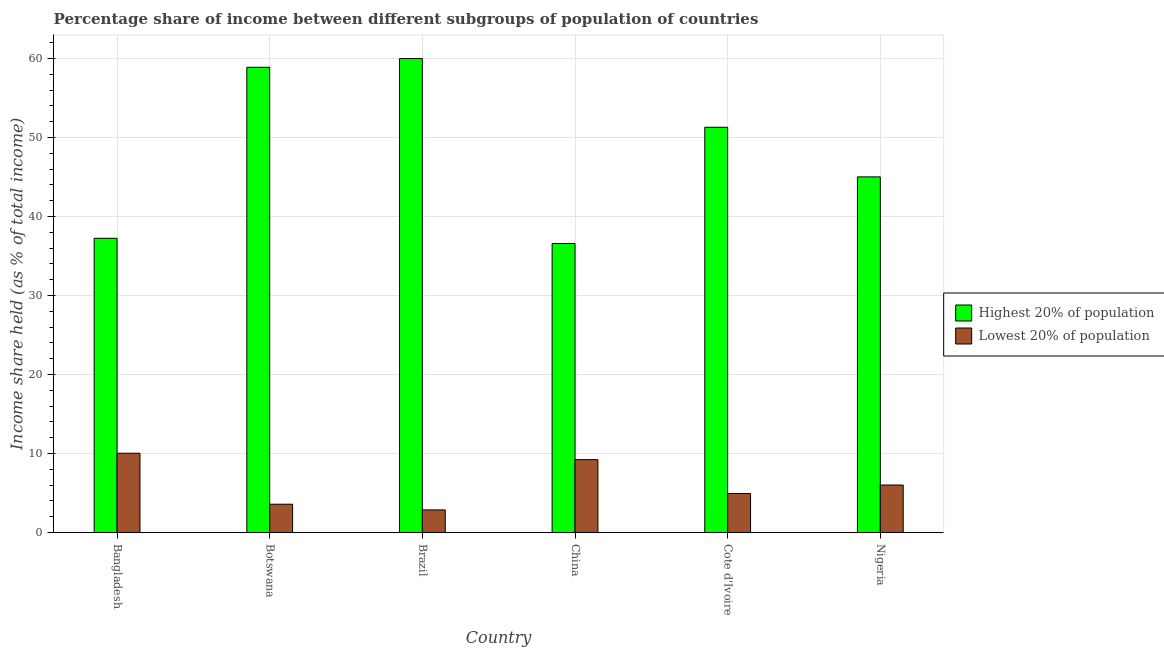How many different coloured bars are there?
Offer a terse response. 2. How many groups of bars are there?
Provide a succinct answer. 6. Are the number of bars per tick equal to the number of legend labels?
Your answer should be compact. Yes. Are the number of bars on each tick of the X-axis equal?
Your answer should be very brief. Yes. How many bars are there on the 5th tick from the left?
Make the answer very short. 2. In how many cases, is the number of bars for a given country not equal to the number of legend labels?
Give a very brief answer. 0. What is the income share held by highest 20% of the population in Nigeria?
Offer a terse response. 45.01. Across all countries, what is the maximum income share held by lowest 20% of the population?
Keep it short and to the point. 10.04. Across all countries, what is the minimum income share held by highest 20% of the population?
Offer a very short reply. 36.58. In which country was the income share held by lowest 20% of the population minimum?
Keep it short and to the point. Brazil. What is the total income share held by lowest 20% of the population in the graph?
Give a very brief answer. 36.7. What is the difference between the income share held by lowest 20% of the population in China and that in Cote d'Ivoire?
Keep it short and to the point. 4.28. What is the difference between the income share held by highest 20% of the population in Botswana and the income share held by lowest 20% of the population in Nigeria?
Ensure brevity in your answer.  52.86. What is the average income share held by lowest 20% of the population per country?
Offer a terse response. 6.12. What is the difference between the income share held by highest 20% of the population and income share held by lowest 20% of the population in Cote d'Ivoire?
Ensure brevity in your answer.  46.34. In how many countries, is the income share held by highest 20% of the population greater than 26 %?
Make the answer very short. 6. What is the ratio of the income share held by lowest 20% of the population in Botswana to that in China?
Provide a short and direct response. 0.39. Is the difference between the income share held by lowest 20% of the population in Bangladesh and Brazil greater than the difference between the income share held by highest 20% of the population in Bangladesh and Brazil?
Provide a succinct answer. Yes. What is the difference between the highest and the second highest income share held by lowest 20% of the population?
Give a very brief answer. 0.81. What is the difference between the highest and the lowest income share held by lowest 20% of the population?
Ensure brevity in your answer.  7.17. In how many countries, is the income share held by highest 20% of the population greater than the average income share held by highest 20% of the population taken over all countries?
Offer a very short reply. 3. Is the sum of the income share held by highest 20% of the population in Bangladesh and Botswana greater than the maximum income share held by lowest 20% of the population across all countries?
Your answer should be very brief. Yes. What does the 1st bar from the left in Nigeria represents?
Ensure brevity in your answer.  Highest 20% of population. What does the 2nd bar from the right in Botswana represents?
Provide a short and direct response. Highest 20% of population. How many countries are there in the graph?
Provide a short and direct response. 6. Are the values on the major ticks of Y-axis written in scientific E-notation?
Offer a terse response. No. Does the graph contain any zero values?
Keep it short and to the point. No. Does the graph contain grids?
Give a very brief answer. Yes. How many legend labels are there?
Your answer should be compact. 2. How are the legend labels stacked?
Provide a short and direct response. Vertical. What is the title of the graph?
Make the answer very short. Percentage share of income between different subgroups of population of countries. Does "Pregnant women" appear as one of the legend labels in the graph?
Give a very brief answer. No. What is the label or title of the X-axis?
Ensure brevity in your answer.  Country. What is the label or title of the Y-axis?
Ensure brevity in your answer.  Income share held (as % of total income). What is the Income share held (as % of total income) in Highest 20% of population in Bangladesh?
Make the answer very short. 37.24. What is the Income share held (as % of total income) in Lowest 20% of population in Bangladesh?
Offer a terse response. 10.04. What is the Income share held (as % of total income) in Highest 20% of population in Botswana?
Your response must be concise. 58.88. What is the Income share held (as % of total income) of Lowest 20% of population in Botswana?
Keep it short and to the point. 3.59. What is the Income share held (as % of total income) in Highest 20% of population in Brazil?
Your answer should be very brief. 59.98. What is the Income share held (as % of total income) of Lowest 20% of population in Brazil?
Provide a short and direct response. 2.87. What is the Income share held (as % of total income) in Highest 20% of population in China?
Offer a very short reply. 36.58. What is the Income share held (as % of total income) of Lowest 20% of population in China?
Give a very brief answer. 9.23. What is the Income share held (as % of total income) of Highest 20% of population in Cote d'Ivoire?
Make the answer very short. 51.29. What is the Income share held (as % of total income) of Lowest 20% of population in Cote d'Ivoire?
Make the answer very short. 4.95. What is the Income share held (as % of total income) in Highest 20% of population in Nigeria?
Make the answer very short. 45.01. What is the Income share held (as % of total income) of Lowest 20% of population in Nigeria?
Ensure brevity in your answer.  6.02. Across all countries, what is the maximum Income share held (as % of total income) in Highest 20% of population?
Ensure brevity in your answer.  59.98. Across all countries, what is the maximum Income share held (as % of total income) in Lowest 20% of population?
Your answer should be compact. 10.04. Across all countries, what is the minimum Income share held (as % of total income) of Highest 20% of population?
Provide a succinct answer. 36.58. Across all countries, what is the minimum Income share held (as % of total income) in Lowest 20% of population?
Provide a succinct answer. 2.87. What is the total Income share held (as % of total income) of Highest 20% of population in the graph?
Your answer should be very brief. 288.98. What is the total Income share held (as % of total income) of Lowest 20% of population in the graph?
Give a very brief answer. 36.7. What is the difference between the Income share held (as % of total income) of Highest 20% of population in Bangladesh and that in Botswana?
Your response must be concise. -21.64. What is the difference between the Income share held (as % of total income) in Lowest 20% of population in Bangladesh and that in Botswana?
Keep it short and to the point. 6.45. What is the difference between the Income share held (as % of total income) of Highest 20% of population in Bangladesh and that in Brazil?
Ensure brevity in your answer.  -22.74. What is the difference between the Income share held (as % of total income) of Lowest 20% of population in Bangladesh and that in Brazil?
Keep it short and to the point. 7.17. What is the difference between the Income share held (as % of total income) in Highest 20% of population in Bangladesh and that in China?
Give a very brief answer. 0.66. What is the difference between the Income share held (as % of total income) in Lowest 20% of population in Bangladesh and that in China?
Ensure brevity in your answer.  0.81. What is the difference between the Income share held (as % of total income) of Highest 20% of population in Bangladesh and that in Cote d'Ivoire?
Ensure brevity in your answer.  -14.05. What is the difference between the Income share held (as % of total income) of Lowest 20% of population in Bangladesh and that in Cote d'Ivoire?
Provide a succinct answer. 5.09. What is the difference between the Income share held (as % of total income) of Highest 20% of population in Bangladesh and that in Nigeria?
Your response must be concise. -7.77. What is the difference between the Income share held (as % of total income) of Lowest 20% of population in Bangladesh and that in Nigeria?
Give a very brief answer. 4.02. What is the difference between the Income share held (as % of total income) of Highest 20% of population in Botswana and that in Brazil?
Your answer should be very brief. -1.1. What is the difference between the Income share held (as % of total income) in Lowest 20% of population in Botswana and that in Brazil?
Provide a succinct answer. 0.72. What is the difference between the Income share held (as % of total income) in Highest 20% of population in Botswana and that in China?
Keep it short and to the point. 22.3. What is the difference between the Income share held (as % of total income) of Lowest 20% of population in Botswana and that in China?
Your answer should be very brief. -5.64. What is the difference between the Income share held (as % of total income) in Highest 20% of population in Botswana and that in Cote d'Ivoire?
Give a very brief answer. 7.59. What is the difference between the Income share held (as % of total income) in Lowest 20% of population in Botswana and that in Cote d'Ivoire?
Give a very brief answer. -1.36. What is the difference between the Income share held (as % of total income) in Highest 20% of population in Botswana and that in Nigeria?
Give a very brief answer. 13.87. What is the difference between the Income share held (as % of total income) of Lowest 20% of population in Botswana and that in Nigeria?
Your response must be concise. -2.43. What is the difference between the Income share held (as % of total income) of Highest 20% of population in Brazil and that in China?
Provide a short and direct response. 23.4. What is the difference between the Income share held (as % of total income) of Lowest 20% of population in Brazil and that in China?
Offer a very short reply. -6.36. What is the difference between the Income share held (as % of total income) of Highest 20% of population in Brazil and that in Cote d'Ivoire?
Ensure brevity in your answer.  8.69. What is the difference between the Income share held (as % of total income) of Lowest 20% of population in Brazil and that in Cote d'Ivoire?
Offer a terse response. -2.08. What is the difference between the Income share held (as % of total income) in Highest 20% of population in Brazil and that in Nigeria?
Keep it short and to the point. 14.97. What is the difference between the Income share held (as % of total income) of Lowest 20% of population in Brazil and that in Nigeria?
Keep it short and to the point. -3.15. What is the difference between the Income share held (as % of total income) in Highest 20% of population in China and that in Cote d'Ivoire?
Ensure brevity in your answer.  -14.71. What is the difference between the Income share held (as % of total income) of Lowest 20% of population in China and that in Cote d'Ivoire?
Provide a succinct answer. 4.28. What is the difference between the Income share held (as % of total income) in Highest 20% of population in China and that in Nigeria?
Your answer should be compact. -8.43. What is the difference between the Income share held (as % of total income) of Lowest 20% of population in China and that in Nigeria?
Keep it short and to the point. 3.21. What is the difference between the Income share held (as % of total income) of Highest 20% of population in Cote d'Ivoire and that in Nigeria?
Your answer should be compact. 6.28. What is the difference between the Income share held (as % of total income) of Lowest 20% of population in Cote d'Ivoire and that in Nigeria?
Give a very brief answer. -1.07. What is the difference between the Income share held (as % of total income) of Highest 20% of population in Bangladesh and the Income share held (as % of total income) of Lowest 20% of population in Botswana?
Ensure brevity in your answer.  33.65. What is the difference between the Income share held (as % of total income) in Highest 20% of population in Bangladesh and the Income share held (as % of total income) in Lowest 20% of population in Brazil?
Provide a succinct answer. 34.37. What is the difference between the Income share held (as % of total income) of Highest 20% of population in Bangladesh and the Income share held (as % of total income) of Lowest 20% of population in China?
Offer a terse response. 28.01. What is the difference between the Income share held (as % of total income) in Highest 20% of population in Bangladesh and the Income share held (as % of total income) in Lowest 20% of population in Cote d'Ivoire?
Offer a very short reply. 32.29. What is the difference between the Income share held (as % of total income) of Highest 20% of population in Bangladesh and the Income share held (as % of total income) of Lowest 20% of population in Nigeria?
Keep it short and to the point. 31.22. What is the difference between the Income share held (as % of total income) in Highest 20% of population in Botswana and the Income share held (as % of total income) in Lowest 20% of population in Brazil?
Make the answer very short. 56.01. What is the difference between the Income share held (as % of total income) of Highest 20% of population in Botswana and the Income share held (as % of total income) of Lowest 20% of population in China?
Provide a short and direct response. 49.65. What is the difference between the Income share held (as % of total income) of Highest 20% of population in Botswana and the Income share held (as % of total income) of Lowest 20% of population in Cote d'Ivoire?
Keep it short and to the point. 53.93. What is the difference between the Income share held (as % of total income) of Highest 20% of population in Botswana and the Income share held (as % of total income) of Lowest 20% of population in Nigeria?
Provide a succinct answer. 52.86. What is the difference between the Income share held (as % of total income) of Highest 20% of population in Brazil and the Income share held (as % of total income) of Lowest 20% of population in China?
Your answer should be very brief. 50.75. What is the difference between the Income share held (as % of total income) of Highest 20% of population in Brazil and the Income share held (as % of total income) of Lowest 20% of population in Cote d'Ivoire?
Offer a very short reply. 55.03. What is the difference between the Income share held (as % of total income) in Highest 20% of population in Brazil and the Income share held (as % of total income) in Lowest 20% of population in Nigeria?
Give a very brief answer. 53.96. What is the difference between the Income share held (as % of total income) of Highest 20% of population in China and the Income share held (as % of total income) of Lowest 20% of population in Cote d'Ivoire?
Provide a succinct answer. 31.63. What is the difference between the Income share held (as % of total income) of Highest 20% of population in China and the Income share held (as % of total income) of Lowest 20% of population in Nigeria?
Make the answer very short. 30.56. What is the difference between the Income share held (as % of total income) in Highest 20% of population in Cote d'Ivoire and the Income share held (as % of total income) in Lowest 20% of population in Nigeria?
Your response must be concise. 45.27. What is the average Income share held (as % of total income) in Highest 20% of population per country?
Make the answer very short. 48.16. What is the average Income share held (as % of total income) in Lowest 20% of population per country?
Keep it short and to the point. 6.12. What is the difference between the Income share held (as % of total income) of Highest 20% of population and Income share held (as % of total income) of Lowest 20% of population in Bangladesh?
Make the answer very short. 27.2. What is the difference between the Income share held (as % of total income) of Highest 20% of population and Income share held (as % of total income) of Lowest 20% of population in Botswana?
Your answer should be very brief. 55.29. What is the difference between the Income share held (as % of total income) of Highest 20% of population and Income share held (as % of total income) of Lowest 20% of population in Brazil?
Provide a short and direct response. 57.11. What is the difference between the Income share held (as % of total income) of Highest 20% of population and Income share held (as % of total income) of Lowest 20% of population in China?
Provide a short and direct response. 27.35. What is the difference between the Income share held (as % of total income) of Highest 20% of population and Income share held (as % of total income) of Lowest 20% of population in Cote d'Ivoire?
Your answer should be compact. 46.34. What is the difference between the Income share held (as % of total income) in Highest 20% of population and Income share held (as % of total income) in Lowest 20% of population in Nigeria?
Give a very brief answer. 38.99. What is the ratio of the Income share held (as % of total income) of Highest 20% of population in Bangladesh to that in Botswana?
Your response must be concise. 0.63. What is the ratio of the Income share held (as % of total income) of Lowest 20% of population in Bangladesh to that in Botswana?
Ensure brevity in your answer.  2.8. What is the ratio of the Income share held (as % of total income) in Highest 20% of population in Bangladesh to that in Brazil?
Ensure brevity in your answer.  0.62. What is the ratio of the Income share held (as % of total income) in Lowest 20% of population in Bangladesh to that in Brazil?
Give a very brief answer. 3.5. What is the ratio of the Income share held (as % of total income) in Highest 20% of population in Bangladesh to that in China?
Keep it short and to the point. 1.02. What is the ratio of the Income share held (as % of total income) in Lowest 20% of population in Bangladesh to that in China?
Ensure brevity in your answer.  1.09. What is the ratio of the Income share held (as % of total income) of Highest 20% of population in Bangladesh to that in Cote d'Ivoire?
Provide a short and direct response. 0.73. What is the ratio of the Income share held (as % of total income) in Lowest 20% of population in Bangladesh to that in Cote d'Ivoire?
Make the answer very short. 2.03. What is the ratio of the Income share held (as % of total income) of Highest 20% of population in Bangladesh to that in Nigeria?
Ensure brevity in your answer.  0.83. What is the ratio of the Income share held (as % of total income) in Lowest 20% of population in Bangladesh to that in Nigeria?
Make the answer very short. 1.67. What is the ratio of the Income share held (as % of total income) of Highest 20% of population in Botswana to that in Brazil?
Your answer should be very brief. 0.98. What is the ratio of the Income share held (as % of total income) of Lowest 20% of population in Botswana to that in Brazil?
Your answer should be compact. 1.25. What is the ratio of the Income share held (as % of total income) of Highest 20% of population in Botswana to that in China?
Give a very brief answer. 1.61. What is the ratio of the Income share held (as % of total income) of Lowest 20% of population in Botswana to that in China?
Your response must be concise. 0.39. What is the ratio of the Income share held (as % of total income) in Highest 20% of population in Botswana to that in Cote d'Ivoire?
Give a very brief answer. 1.15. What is the ratio of the Income share held (as % of total income) in Lowest 20% of population in Botswana to that in Cote d'Ivoire?
Your response must be concise. 0.73. What is the ratio of the Income share held (as % of total income) in Highest 20% of population in Botswana to that in Nigeria?
Your answer should be compact. 1.31. What is the ratio of the Income share held (as % of total income) in Lowest 20% of population in Botswana to that in Nigeria?
Make the answer very short. 0.6. What is the ratio of the Income share held (as % of total income) in Highest 20% of population in Brazil to that in China?
Provide a succinct answer. 1.64. What is the ratio of the Income share held (as % of total income) in Lowest 20% of population in Brazil to that in China?
Keep it short and to the point. 0.31. What is the ratio of the Income share held (as % of total income) of Highest 20% of population in Brazil to that in Cote d'Ivoire?
Keep it short and to the point. 1.17. What is the ratio of the Income share held (as % of total income) of Lowest 20% of population in Brazil to that in Cote d'Ivoire?
Give a very brief answer. 0.58. What is the ratio of the Income share held (as % of total income) of Highest 20% of population in Brazil to that in Nigeria?
Give a very brief answer. 1.33. What is the ratio of the Income share held (as % of total income) in Lowest 20% of population in Brazil to that in Nigeria?
Your response must be concise. 0.48. What is the ratio of the Income share held (as % of total income) in Highest 20% of population in China to that in Cote d'Ivoire?
Make the answer very short. 0.71. What is the ratio of the Income share held (as % of total income) in Lowest 20% of population in China to that in Cote d'Ivoire?
Ensure brevity in your answer.  1.86. What is the ratio of the Income share held (as % of total income) of Highest 20% of population in China to that in Nigeria?
Give a very brief answer. 0.81. What is the ratio of the Income share held (as % of total income) of Lowest 20% of population in China to that in Nigeria?
Your response must be concise. 1.53. What is the ratio of the Income share held (as % of total income) in Highest 20% of population in Cote d'Ivoire to that in Nigeria?
Your answer should be very brief. 1.14. What is the ratio of the Income share held (as % of total income) of Lowest 20% of population in Cote d'Ivoire to that in Nigeria?
Make the answer very short. 0.82. What is the difference between the highest and the second highest Income share held (as % of total income) of Highest 20% of population?
Make the answer very short. 1.1. What is the difference between the highest and the second highest Income share held (as % of total income) in Lowest 20% of population?
Your answer should be very brief. 0.81. What is the difference between the highest and the lowest Income share held (as % of total income) of Highest 20% of population?
Ensure brevity in your answer.  23.4. What is the difference between the highest and the lowest Income share held (as % of total income) in Lowest 20% of population?
Keep it short and to the point. 7.17. 